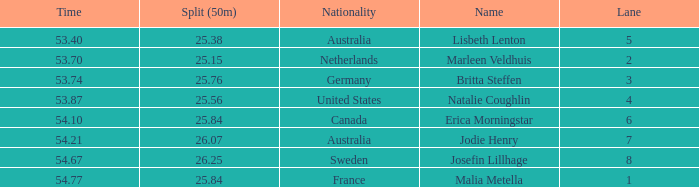What is the total sum of 50m splits for josefin lillhage in lanes above 8? None. 